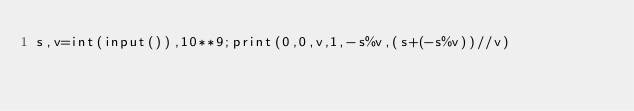Convert code to text. <code><loc_0><loc_0><loc_500><loc_500><_Python_>s,v=int(input()),10**9;print(0,0,v,1,-s%v,(s+(-s%v))//v)</code> 